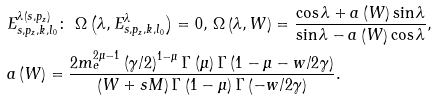<formula> <loc_0><loc_0><loc_500><loc_500>& E _ { s , p _ { z } , k , l _ { 0 } } ^ { \lambda \left ( s , p _ { z } \right ) } \colon \ \Omega \left ( \lambda , E _ { s , p _ { z } , k , l _ { 0 } } ^ { \lambda } \right ) = 0 , \, \Omega \left ( \lambda , W \right ) = \frac { \cos \lambda + a \left ( W \right ) \sin \lambda } { \sin \lambda - a \left ( W \right ) \cos \lambda } , \\ & a \left ( W \right ) = \frac { 2 m _ { e } ^ { 2 \mu - 1 } \left ( \gamma / 2 \right ) ^ { 1 - \mu } \Gamma \left ( \mu \right ) \Gamma \left ( 1 - \mu - w / 2 \gamma \right ) } { \left ( W + s M \right ) \Gamma \left ( 1 - \mu \right ) \Gamma \left ( - w / 2 \gamma \right ) } .</formula> 